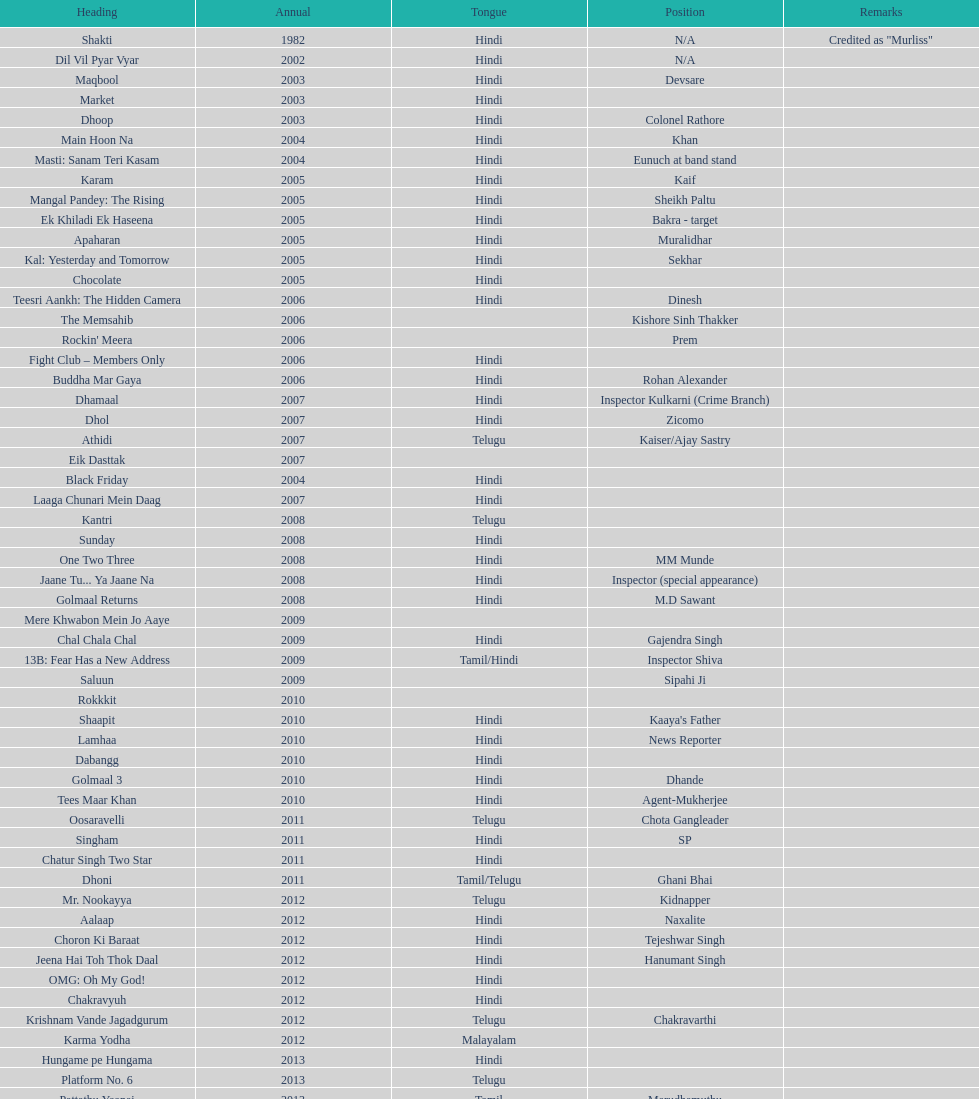What title is before dhol in 2007? Dhamaal. 